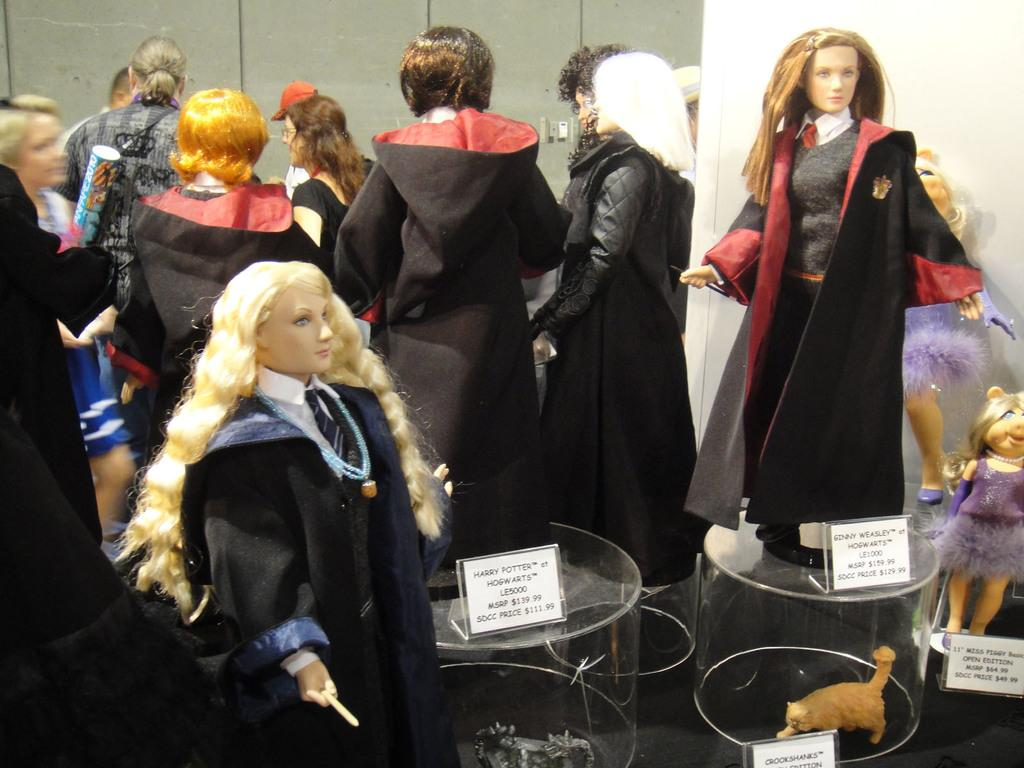What are the dolls placed on in the image? The dolls are placed on glass objects. What else can be seen on the glass objects besides the dolls? There are boards on the glass objects. What is visible in the background of the image? There is a wall in the background of the image. What type of pump is visible in the image? There is no pump present in the image. How does the temper of the dolls change throughout the month in the image? The image does not show any dolls changing temper or any indication of time passing, so it cannot be determined from the image. 